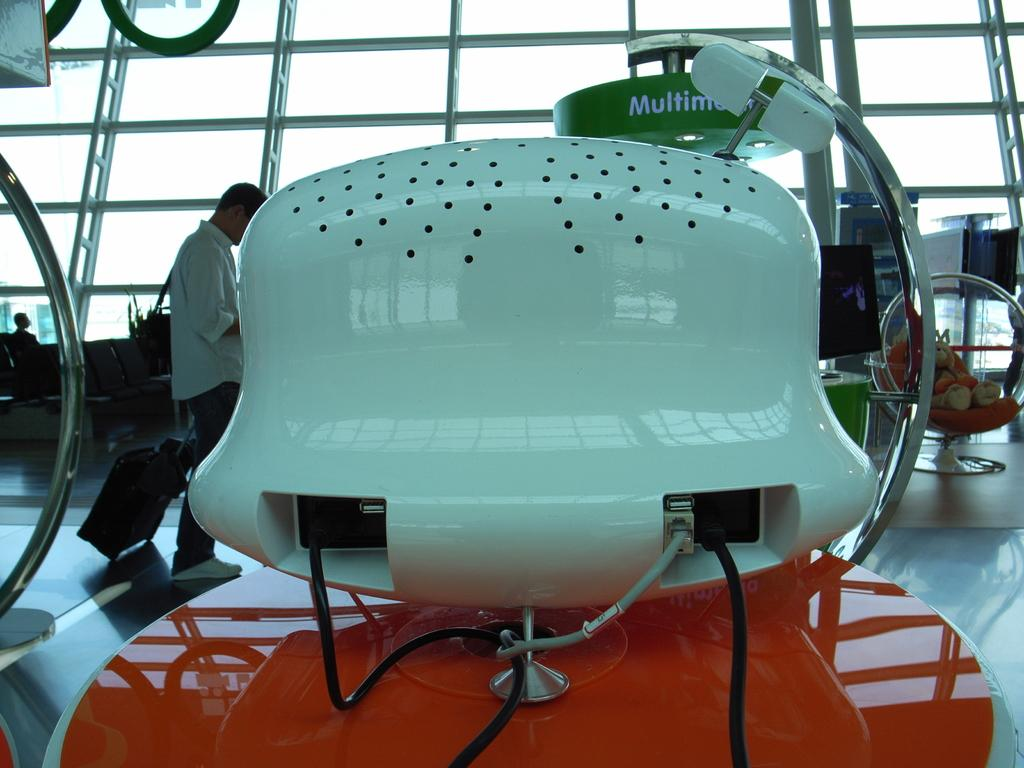What object in the image is likely to be used for communication or entertainment? There is an electronic device in the image, which is likely to be used for communication or entertainment. What type of furniture can be seen in the background of the image? There are chairs in the background of the image. What is the person in the image carrying? The person is holding a trolley bag in the image. What type of structural element is present in the image? There are iron rods in the image. Where is the doll located in the image? There is a doll on a chair in the image? What type of soup is being served in the image? There is no soup present in the image. How many sugar cubes are visible on the table in the image? There is no sugar present in the image. 